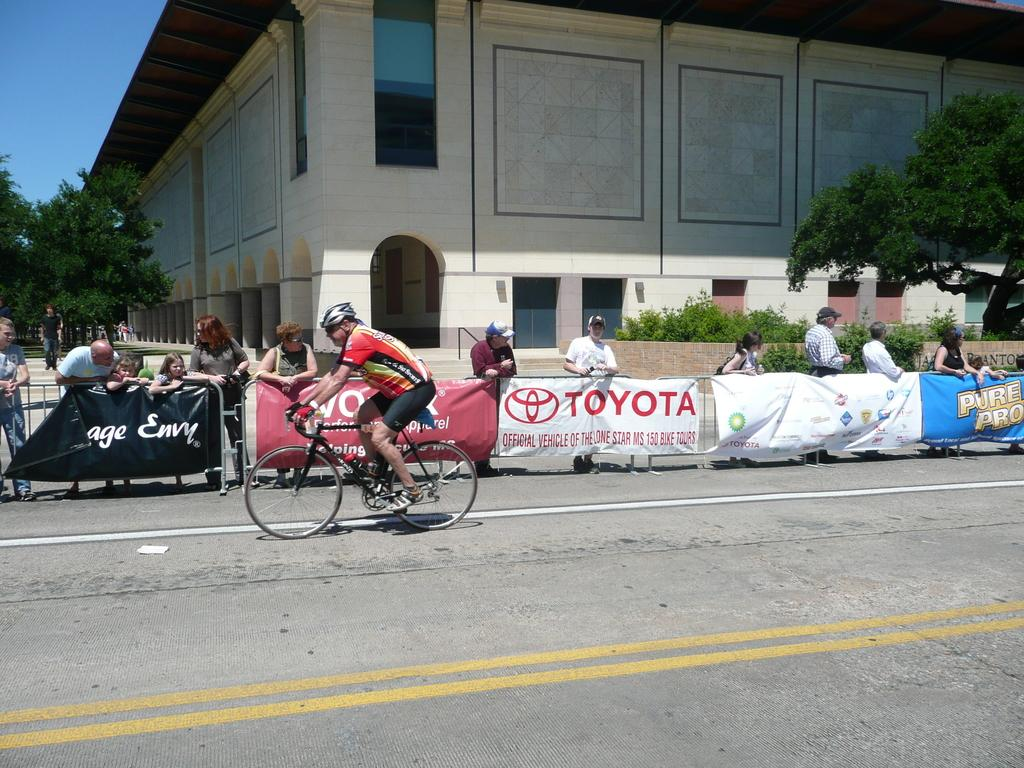What is the main subject of the image? There is a person riding a bicycle in the image. What can be seen in the background of the image? There is a fence, a building, and trees in the image. Are there any other people in the image besides the person riding the bicycle? Yes, people are standing near the fence in the image. What type of bit is the person riding the bicycle using to communicate with the horse? There is no horse present in the image, and the person is riding a bicycle, not a horse. Therefore, there is no bit involved in this scenario. 